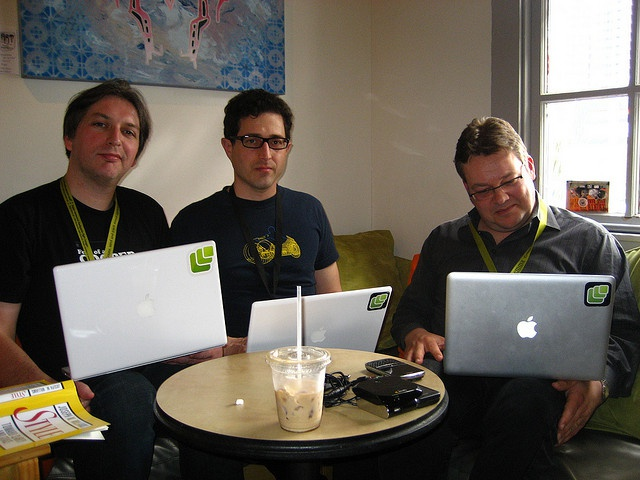Describe the objects in this image and their specific colors. I can see people in maroon, black, lightgray, and olive tones, people in maroon, black, and gray tones, people in maroon, black, and gray tones, laptop in maroon, lightgray, and darkgray tones, and laptop in maroon, gray, darkgray, white, and black tones in this image. 